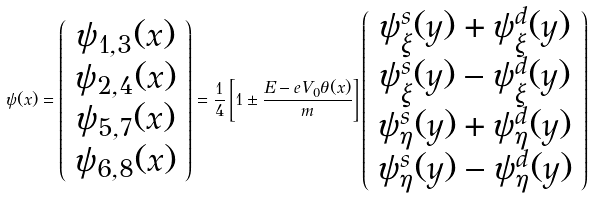Convert formula to latex. <formula><loc_0><loc_0><loc_500><loc_500>\psi ( x ) = \left ( \begin{array} { c } \psi _ { 1 , 3 } ( x ) \\ \psi _ { 2 , 4 } ( x ) \\ \psi _ { 5 , 7 } ( x ) \\ \psi _ { 6 , 8 } ( x ) \end{array} \right ) = \frac { 1 } { 4 } \left [ 1 \pm \frac { E - e V _ { 0 } \theta ( x ) } { m } \right ] \left ( \begin{array} { c } \psi _ { \xi } ^ { s } ( y ) + \psi _ { \xi } ^ { d } ( y ) \\ \psi _ { \xi } ^ { s } ( y ) - \psi _ { \xi } ^ { d } ( y ) \\ \psi _ { \eta } ^ { s } ( y ) + \psi _ { \eta } ^ { d } ( y ) \\ \psi _ { \eta } ^ { s } ( y ) - \psi _ { \eta } ^ { d } ( y ) \end{array} \right )</formula> 